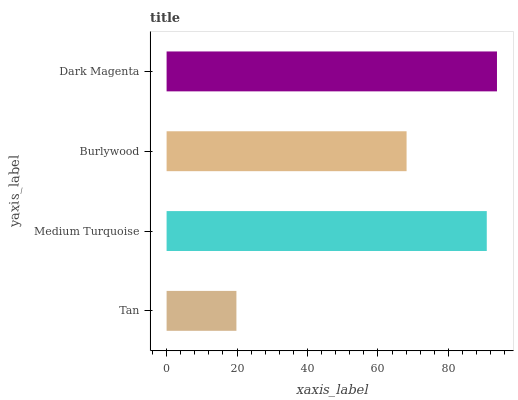Is Tan the minimum?
Answer yes or no. Yes. Is Dark Magenta the maximum?
Answer yes or no. Yes. Is Medium Turquoise the minimum?
Answer yes or no. No. Is Medium Turquoise the maximum?
Answer yes or no. No. Is Medium Turquoise greater than Tan?
Answer yes or no. Yes. Is Tan less than Medium Turquoise?
Answer yes or no. Yes. Is Tan greater than Medium Turquoise?
Answer yes or no. No. Is Medium Turquoise less than Tan?
Answer yes or no. No. Is Medium Turquoise the high median?
Answer yes or no. Yes. Is Burlywood the low median?
Answer yes or no. Yes. Is Tan the high median?
Answer yes or no. No. Is Dark Magenta the low median?
Answer yes or no. No. 